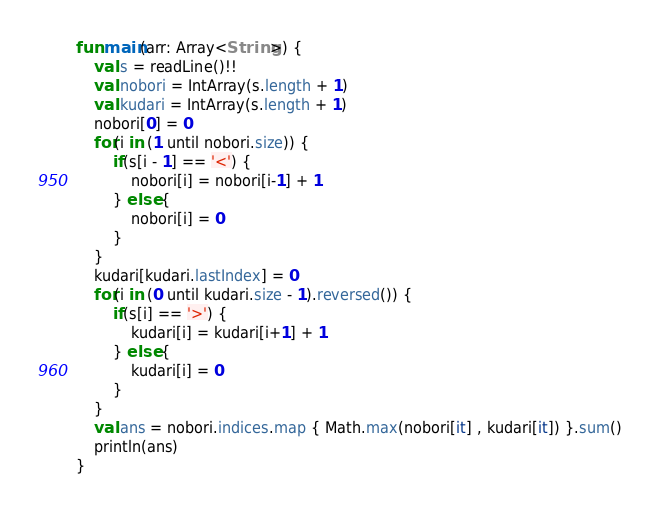Convert code to text. <code><loc_0><loc_0><loc_500><loc_500><_Kotlin_>fun main(arr: Array<String>) {
    val s = readLine()!!
    val nobori = IntArray(s.length + 1)
    val kudari = IntArray(s.length + 1)
    nobori[0] = 0
    for(i in (1 until nobori.size)) {
        if(s[i - 1] == '<') {
            nobori[i] = nobori[i-1] + 1
        } else {
            nobori[i] = 0
        }
    }
    kudari[kudari.lastIndex] = 0
    for(i in (0 until kudari.size - 1).reversed()) {
        if(s[i] == '>') {
            kudari[i] = kudari[i+1] + 1
        } else {
            kudari[i] = 0
        }
    }
    val ans = nobori.indices.map { Math.max(nobori[it] , kudari[it]) }.sum()
    println(ans)
}

</code> 